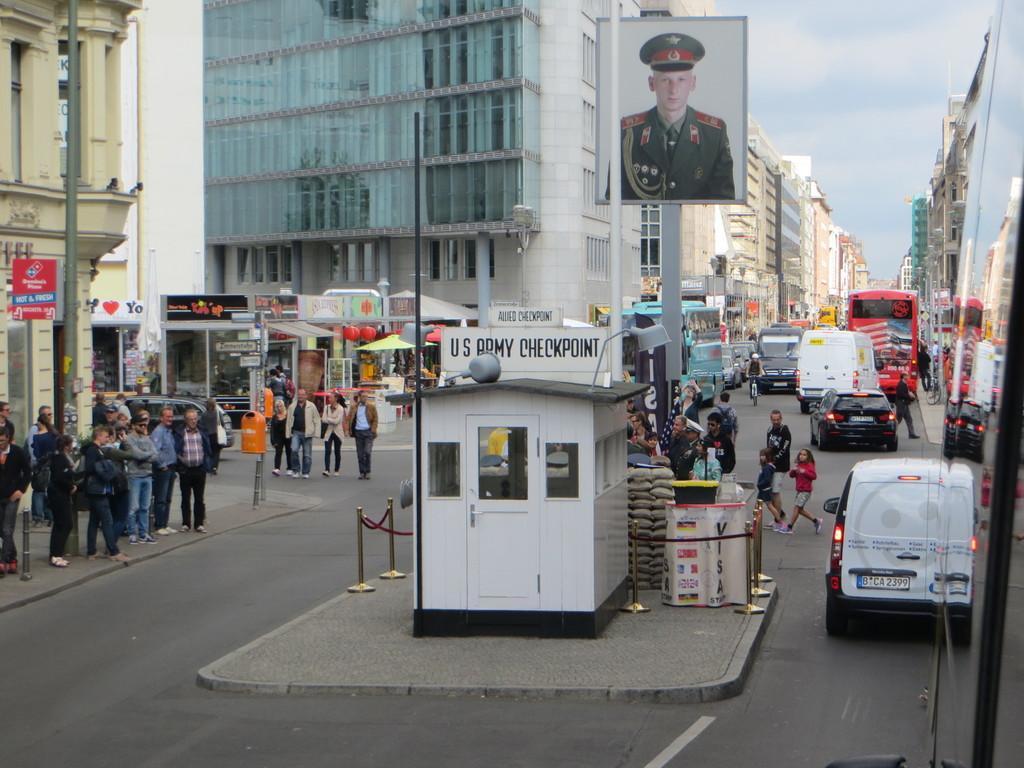Please provide a concise description of this image. In this picture we can see so many buildings, few people are walking on the road ad we can see few vehicles are on the road, in the middle of the road we can see board of a person. 